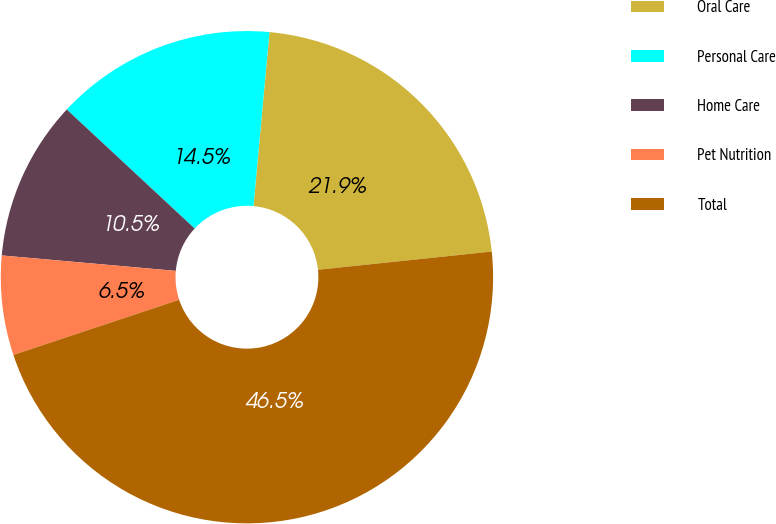<chart> <loc_0><loc_0><loc_500><loc_500><pie_chart><fcel>Oral Care<fcel>Personal Care<fcel>Home Care<fcel>Pet Nutrition<fcel>Total<nl><fcel>21.88%<fcel>14.53%<fcel>10.52%<fcel>6.52%<fcel>46.55%<nl></chart> 